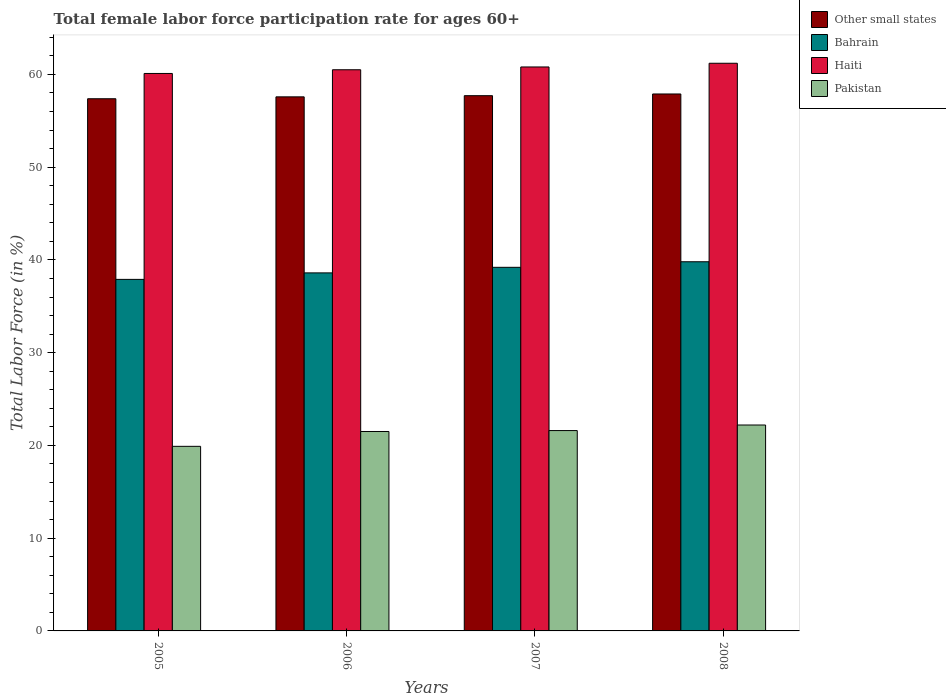How many different coloured bars are there?
Offer a terse response. 4. How many groups of bars are there?
Your answer should be compact. 4. Are the number of bars per tick equal to the number of legend labels?
Your response must be concise. Yes. How many bars are there on the 3rd tick from the left?
Provide a short and direct response. 4. How many bars are there on the 4th tick from the right?
Offer a terse response. 4. What is the female labor force participation rate in Pakistan in 2008?
Make the answer very short. 22.2. Across all years, what is the maximum female labor force participation rate in Bahrain?
Offer a terse response. 39.8. Across all years, what is the minimum female labor force participation rate in Haiti?
Keep it short and to the point. 60.1. What is the total female labor force participation rate in Other small states in the graph?
Your answer should be compact. 230.55. What is the difference between the female labor force participation rate in Other small states in 2006 and that in 2008?
Offer a terse response. -0.31. What is the difference between the female labor force participation rate in Other small states in 2008 and the female labor force participation rate in Pakistan in 2006?
Provide a short and direct response. 36.39. What is the average female labor force participation rate in Haiti per year?
Make the answer very short. 60.65. In the year 2005, what is the difference between the female labor force participation rate in Bahrain and female labor force participation rate in Pakistan?
Your response must be concise. 18. In how many years, is the female labor force participation rate in Bahrain greater than 12 %?
Provide a succinct answer. 4. What is the ratio of the female labor force participation rate in Haiti in 2006 to that in 2008?
Your answer should be very brief. 0.99. What is the difference between the highest and the second highest female labor force participation rate in Bahrain?
Provide a short and direct response. 0.6. What is the difference between the highest and the lowest female labor force participation rate in Bahrain?
Keep it short and to the point. 1.9. Is the sum of the female labor force participation rate in Pakistan in 2006 and 2008 greater than the maximum female labor force participation rate in Other small states across all years?
Offer a terse response. No. Is it the case that in every year, the sum of the female labor force participation rate in Bahrain and female labor force participation rate in Haiti is greater than the sum of female labor force participation rate in Pakistan and female labor force participation rate in Other small states?
Give a very brief answer. Yes. What does the 4th bar from the right in 2008 represents?
Provide a succinct answer. Other small states. Is it the case that in every year, the sum of the female labor force participation rate in Bahrain and female labor force participation rate in Haiti is greater than the female labor force participation rate in Pakistan?
Provide a short and direct response. Yes. Are all the bars in the graph horizontal?
Make the answer very short. No. How many years are there in the graph?
Give a very brief answer. 4. Where does the legend appear in the graph?
Give a very brief answer. Top right. How are the legend labels stacked?
Your answer should be very brief. Vertical. What is the title of the graph?
Ensure brevity in your answer.  Total female labor force participation rate for ages 60+. Does "Low income" appear as one of the legend labels in the graph?
Your response must be concise. No. What is the Total Labor Force (in %) in Other small states in 2005?
Your answer should be compact. 57.37. What is the Total Labor Force (in %) of Bahrain in 2005?
Make the answer very short. 37.9. What is the Total Labor Force (in %) in Haiti in 2005?
Give a very brief answer. 60.1. What is the Total Labor Force (in %) of Pakistan in 2005?
Offer a terse response. 19.9. What is the Total Labor Force (in %) of Other small states in 2006?
Give a very brief answer. 57.58. What is the Total Labor Force (in %) of Bahrain in 2006?
Offer a terse response. 38.6. What is the Total Labor Force (in %) in Haiti in 2006?
Give a very brief answer. 60.5. What is the Total Labor Force (in %) of Other small states in 2007?
Offer a terse response. 57.7. What is the Total Labor Force (in %) in Bahrain in 2007?
Your response must be concise. 39.2. What is the Total Labor Force (in %) of Haiti in 2007?
Your answer should be compact. 60.8. What is the Total Labor Force (in %) of Pakistan in 2007?
Your answer should be compact. 21.6. What is the Total Labor Force (in %) of Other small states in 2008?
Provide a succinct answer. 57.89. What is the Total Labor Force (in %) in Bahrain in 2008?
Your answer should be very brief. 39.8. What is the Total Labor Force (in %) in Haiti in 2008?
Give a very brief answer. 61.2. What is the Total Labor Force (in %) of Pakistan in 2008?
Keep it short and to the point. 22.2. Across all years, what is the maximum Total Labor Force (in %) of Other small states?
Your answer should be very brief. 57.89. Across all years, what is the maximum Total Labor Force (in %) in Bahrain?
Make the answer very short. 39.8. Across all years, what is the maximum Total Labor Force (in %) of Haiti?
Provide a succinct answer. 61.2. Across all years, what is the maximum Total Labor Force (in %) in Pakistan?
Give a very brief answer. 22.2. Across all years, what is the minimum Total Labor Force (in %) of Other small states?
Give a very brief answer. 57.37. Across all years, what is the minimum Total Labor Force (in %) of Bahrain?
Your response must be concise. 37.9. Across all years, what is the minimum Total Labor Force (in %) of Haiti?
Give a very brief answer. 60.1. Across all years, what is the minimum Total Labor Force (in %) in Pakistan?
Make the answer very short. 19.9. What is the total Total Labor Force (in %) in Other small states in the graph?
Provide a short and direct response. 230.55. What is the total Total Labor Force (in %) of Bahrain in the graph?
Make the answer very short. 155.5. What is the total Total Labor Force (in %) in Haiti in the graph?
Your answer should be very brief. 242.6. What is the total Total Labor Force (in %) of Pakistan in the graph?
Give a very brief answer. 85.2. What is the difference between the Total Labor Force (in %) in Other small states in 2005 and that in 2006?
Your response must be concise. -0.2. What is the difference between the Total Labor Force (in %) in Bahrain in 2005 and that in 2006?
Your answer should be compact. -0.7. What is the difference between the Total Labor Force (in %) in Pakistan in 2005 and that in 2006?
Make the answer very short. -1.6. What is the difference between the Total Labor Force (in %) of Other small states in 2005 and that in 2007?
Ensure brevity in your answer.  -0.33. What is the difference between the Total Labor Force (in %) in Other small states in 2005 and that in 2008?
Provide a succinct answer. -0.52. What is the difference between the Total Labor Force (in %) in Bahrain in 2005 and that in 2008?
Keep it short and to the point. -1.9. What is the difference between the Total Labor Force (in %) of Haiti in 2005 and that in 2008?
Make the answer very short. -1.1. What is the difference between the Total Labor Force (in %) of Other small states in 2006 and that in 2007?
Offer a very short reply. -0.13. What is the difference between the Total Labor Force (in %) of Bahrain in 2006 and that in 2007?
Your answer should be compact. -0.6. What is the difference between the Total Labor Force (in %) in Haiti in 2006 and that in 2007?
Provide a succinct answer. -0.3. What is the difference between the Total Labor Force (in %) of Pakistan in 2006 and that in 2007?
Ensure brevity in your answer.  -0.1. What is the difference between the Total Labor Force (in %) of Other small states in 2006 and that in 2008?
Your answer should be very brief. -0.31. What is the difference between the Total Labor Force (in %) in Other small states in 2007 and that in 2008?
Give a very brief answer. -0.18. What is the difference between the Total Labor Force (in %) in Bahrain in 2007 and that in 2008?
Provide a short and direct response. -0.6. What is the difference between the Total Labor Force (in %) of Pakistan in 2007 and that in 2008?
Your answer should be compact. -0.6. What is the difference between the Total Labor Force (in %) of Other small states in 2005 and the Total Labor Force (in %) of Bahrain in 2006?
Your answer should be compact. 18.77. What is the difference between the Total Labor Force (in %) in Other small states in 2005 and the Total Labor Force (in %) in Haiti in 2006?
Your response must be concise. -3.13. What is the difference between the Total Labor Force (in %) of Other small states in 2005 and the Total Labor Force (in %) of Pakistan in 2006?
Make the answer very short. 35.87. What is the difference between the Total Labor Force (in %) in Bahrain in 2005 and the Total Labor Force (in %) in Haiti in 2006?
Offer a terse response. -22.6. What is the difference between the Total Labor Force (in %) in Bahrain in 2005 and the Total Labor Force (in %) in Pakistan in 2006?
Keep it short and to the point. 16.4. What is the difference between the Total Labor Force (in %) in Haiti in 2005 and the Total Labor Force (in %) in Pakistan in 2006?
Offer a very short reply. 38.6. What is the difference between the Total Labor Force (in %) of Other small states in 2005 and the Total Labor Force (in %) of Bahrain in 2007?
Give a very brief answer. 18.17. What is the difference between the Total Labor Force (in %) in Other small states in 2005 and the Total Labor Force (in %) in Haiti in 2007?
Your answer should be compact. -3.43. What is the difference between the Total Labor Force (in %) in Other small states in 2005 and the Total Labor Force (in %) in Pakistan in 2007?
Your response must be concise. 35.77. What is the difference between the Total Labor Force (in %) of Bahrain in 2005 and the Total Labor Force (in %) of Haiti in 2007?
Your answer should be very brief. -22.9. What is the difference between the Total Labor Force (in %) in Bahrain in 2005 and the Total Labor Force (in %) in Pakistan in 2007?
Provide a succinct answer. 16.3. What is the difference between the Total Labor Force (in %) in Haiti in 2005 and the Total Labor Force (in %) in Pakistan in 2007?
Your response must be concise. 38.5. What is the difference between the Total Labor Force (in %) in Other small states in 2005 and the Total Labor Force (in %) in Bahrain in 2008?
Provide a succinct answer. 17.57. What is the difference between the Total Labor Force (in %) in Other small states in 2005 and the Total Labor Force (in %) in Haiti in 2008?
Ensure brevity in your answer.  -3.83. What is the difference between the Total Labor Force (in %) in Other small states in 2005 and the Total Labor Force (in %) in Pakistan in 2008?
Your response must be concise. 35.17. What is the difference between the Total Labor Force (in %) in Bahrain in 2005 and the Total Labor Force (in %) in Haiti in 2008?
Make the answer very short. -23.3. What is the difference between the Total Labor Force (in %) in Haiti in 2005 and the Total Labor Force (in %) in Pakistan in 2008?
Your answer should be very brief. 37.9. What is the difference between the Total Labor Force (in %) of Other small states in 2006 and the Total Labor Force (in %) of Bahrain in 2007?
Ensure brevity in your answer.  18.38. What is the difference between the Total Labor Force (in %) of Other small states in 2006 and the Total Labor Force (in %) of Haiti in 2007?
Keep it short and to the point. -3.22. What is the difference between the Total Labor Force (in %) in Other small states in 2006 and the Total Labor Force (in %) in Pakistan in 2007?
Your answer should be compact. 35.98. What is the difference between the Total Labor Force (in %) of Bahrain in 2006 and the Total Labor Force (in %) of Haiti in 2007?
Make the answer very short. -22.2. What is the difference between the Total Labor Force (in %) of Bahrain in 2006 and the Total Labor Force (in %) of Pakistan in 2007?
Offer a terse response. 17. What is the difference between the Total Labor Force (in %) of Haiti in 2006 and the Total Labor Force (in %) of Pakistan in 2007?
Make the answer very short. 38.9. What is the difference between the Total Labor Force (in %) of Other small states in 2006 and the Total Labor Force (in %) of Bahrain in 2008?
Your response must be concise. 17.78. What is the difference between the Total Labor Force (in %) of Other small states in 2006 and the Total Labor Force (in %) of Haiti in 2008?
Make the answer very short. -3.62. What is the difference between the Total Labor Force (in %) of Other small states in 2006 and the Total Labor Force (in %) of Pakistan in 2008?
Ensure brevity in your answer.  35.38. What is the difference between the Total Labor Force (in %) in Bahrain in 2006 and the Total Labor Force (in %) in Haiti in 2008?
Your response must be concise. -22.6. What is the difference between the Total Labor Force (in %) in Haiti in 2006 and the Total Labor Force (in %) in Pakistan in 2008?
Ensure brevity in your answer.  38.3. What is the difference between the Total Labor Force (in %) of Other small states in 2007 and the Total Labor Force (in %) of Bahrain in 2008?
Your answer should be compact. 17.9. What is the difference between the Total Labor Force (in %) of Other small states in 2007 and the Total Labor Force (in %) of Haiti in 2008?
Keep it short and to the point. -3.5. What is the difference between the Total Labor Force (in %) of Other small states in 2007 and the Total Labor Force (in %) of Pakistan in 2008?
Provide a short and direct response. 35.5. What is the difference between the Total Labor Force (in %) in Bahrain in 2007 and the Total Labor Force (in %) in Pakistan in 2008?
Keep it short and to the point. 17. What is the difference between the Total Labor Force (in %) of Haiti in 2007 and the Total Labor Force (in %) of Pakistan in 2008?
Your response must be concise. 38.6. What is the average Total Labor Force (in %) of Other small states per year?
Your response must be concise. 57.64. What is the average Total Labor Force (in %) in Bahrain per year?
Provide a short and direct response. 38.88. What is the average Total Labor Force (in %) in Haiti per year?
Provide a short and direct response. 60.65. What is the average Total Labor Force (in %) of Pakistan per year?
Offer a terse response. 21.3. In the year 2005, what is the difference between the Total Labor Force (in %) of Other small states and Total Labor Force (in %) of Bahrain?
Your answer should be compact. 19.47. In the year 2005, what is the difference between the Total Labor Force (in %) in Other small states and Total Labor Force (in %) in Haiti?
Provide a succinct answer. -2.73. In the year 2005, what is the difference between the Total Labor Force (in %) of Other small states and Total Labor Force (in %) of Pakistan?
Your answer should be compact. 37.47. In the year 2005, what is the difference between the Total Labor Force (in %) of Bahrain and Total Labor Force (in %) of Haiti?
Your answer should be compact. -22.2. In the year 2005, what is the difference between the Total Labor Force (in %) of Haiti and Total Labor Force (in %) of Pakistan?
Your answer should be very brief. 40.2. In the year 2006, what is the difference between the Total Labor Force (in %) of Other small states and Total Labor Force (in %) of Bahrain?
Offer a very short reply. 18.98. In the year 2006, what is the difference between the Total Labor Force (in %) of Other small states and Total Labor Force (in %) of Haiti?
Keep it short and to the point. -2.92. In the year 2006, what is the difference between the Total Labor Force (in %) in Other small states and Total Labor Force (in %) in Pakistan?
Offer a very short reply. 36.08. In the year 2006, what is the difference between the Total Labor Force (in %) in Bahrain and Total Labor Force (in %) in Haiti?
Offer a very short reply. -21.9. In the year 2006, what is the difference between the Total Labor Force (in %) in Bahrain and Total Labor Force (in %) in Pakistan?
Offer a very short reply. 17.1. In the year 2006, what is the difference between the Total Labor Force (in %) of Haiti and Total Labor Force (in %) of Pakistan?
Make the answer very short. 39. In the year 2007, what is the difference between the Total Labor Force (in %) in Other small states and Total Labor Force (in %) in Bahrain?
Your answer should be very brief. 18.5. In the year 2007, what is the difference between the Total Labor Force (in %) of Other small states and Total Labor Force (in %) of Haiti?
Provide a short and direct response. -3.1. In the year 2007, what is the difference between the Total Labor Force (in %) of Other small states and Total Labor Force (in %) of Pakistan?
Provide a short and direct response. 36.1. In the year 2007, what is the difference between the Total Labor Force (in %) of Bahrain and Total Labor Force (in %) of Haiti?
Your response must be concise. -21.6. In the year 2007, what is the difference between the Total Labor Force (in %) of Haiti and Total Labor Force (in %) of Pakistan?
Provide a short and direct response. 39.2. In the year 2008, what is the difference between the Total Labor Force (in %) in Other small states and Total Labor Force (in %) in Bahrain?
Your response must be concise. 18.09. In the year 2008, what is the difference between the Total Labor Force (in %) of Other small states and Total Labor Force (in %) of Haiti?
Provide a succinct answer. -3.31. In the year 2008, what is the difference between the Total Labor Force (in %) of Other small states and Total Labor Force (in %) of Pakistan?
Provide a succinct answer. 35.69. In the year 2008, what is the difference between the Total Labor Force (in %) in Bahrain and Total Labor Force (in %) in Haiti?
Your answer should be very brief. -21.4. In the year 2008, what is the difference between the Total Labor Force (in %) of Bahrain and Total Labor Force (in %) of Pakistan?
Offer a very short reply. 17.6. In the year 2008, what is the difference between the Total Labor Force (in %) in Haiti and Total Labor Force (in %) in Pakistan?
Your answer should be compact. 39. What is the ratio of the Total Labor Force (in %) of Other small states in 2005 to that in 2006?
Your answer should be very brief. 1. What is the ratio of the Total Labor Force (in %) in Bahrain in 2005 to that in 2006?
Your answer should be compact. 0.98. What is the ratio of the Total Labor Force (in %) in Pakistan in 2005 to that in 2006?
Your answer should be compact. 0.93. What is the ratio of the Total Labor Force (in %) in Other small states in 2005 to that in 2007?
Keep it short and to the point. 0.99. What is the ratio of the Total Labor Force (in %) of Bahrain in 2005 to that in 2007?
Offer a terse response. 0.97. What is the ratio of the Total Labor Force (in %) of Haiti in 2005 to that in 2007?
Give a very brief answer. 0.99. What is the ratio of the Total Labor Force (in %) in Pakistan in 2005 to that in 2007?
Your answer should be compact. 0.92. What is the ratio of the Total Labor Force (in %) in Other small states in 2005 to that in 2008?
Give a very brief answer. 0.99. What is the ratio of the Total Labor Force (in %) of Bahrain in 2005 to that in 2008?
Give a very brief answer. 0.95. What is the ratio of the Total Labor Force (in %) of Pakistan in 2005 to that in 2008?
Provide a succinct answer. 0.9. What is the ratio of the Total Labor Force (in %) in Other small states in 2006 to that in 2007?
Give a very brief answer. 1. What is the ratio of the Total Labor Force (in %) in Bahrain in 2006 to that in 2007?
Give a very brief answer. 0.98. What is the ratio of the Total Labor Force (in %) of Pakistan in 2006 to that in 2007?
Offer a terse response. 1. What is the ratio of the Total Labor Force (in %) in Other small states in 2006 to that in 2008?
Offer a terse response. 0.99. What is the ratio of the Total Labor Force (in %) in Bahrain in 2006 to that in 2008?
Give a very brief answer. 0.97. What is the ratio of the Total Labor Force (in %) of Pakistan in 2006 to that in 2008?
Your answer should be compact. 0.97. What is the ratio of the Total Labor Force (in %) of Bahrain in 2007 to that in 2008?
Ensure brevity in your answer.  0.98. What is the ratio of the Total Labor Force (in %) in Pakistan in 2007 to that in 2008?
Keep it short and to the point. 0.97. What is the difference between the highest and the second highest Total Labor Force (in %) in Other small states?
Your answer should be very brief. 0.18. What is the difference between the highest and the second highest Total Labor Force (in %) in Pakistan?
Provide a short and direct response. 0.6. What is the difference between the highest and the lowest Total Labor Force (in %) of Other small states?
Provide a short and direct response. 0.52. What is the difference between the highest and the lowest Total Labor Force (in %) in Bahrain?
Your answer should be very brief. 1.9. What is the difference between the highest and the lowest Total Labor Force (in %) of Haiti?
Your answer should be very brief. 1.1. 